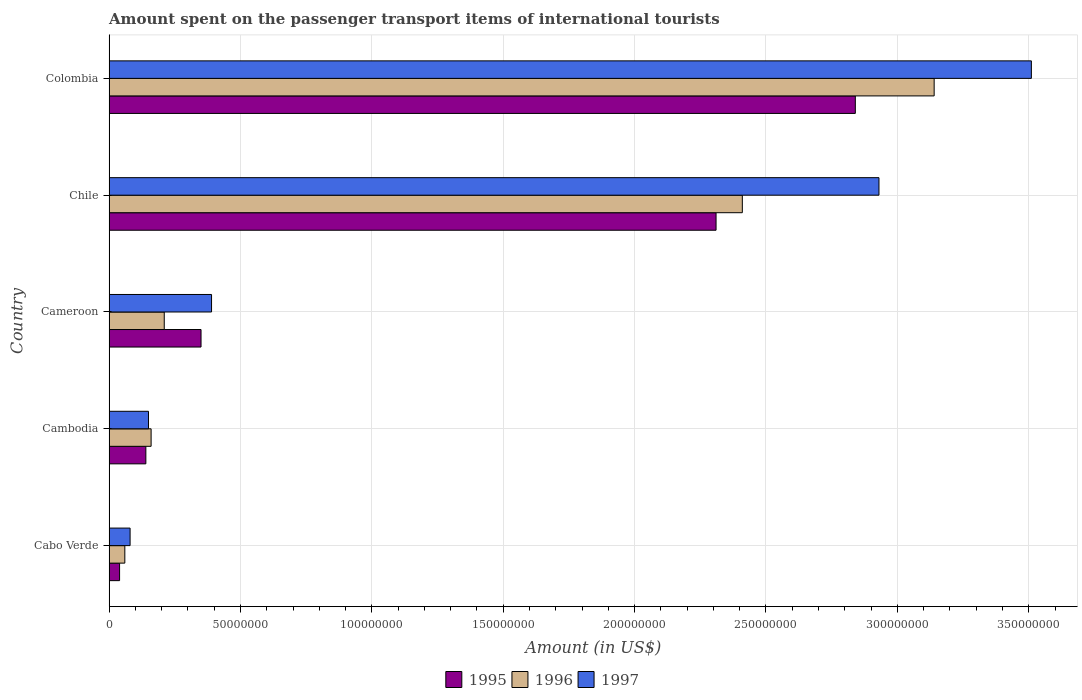How many different coloured bars are there?
Ensure brevity in your answer.  3. Are the number of bars per tick equal to the number of legend labels?
Your answer should be very brief. Yes. Are the number of bars on each tick of the Y-axis equal?
Ensure brevity in your answer.  Yes. How many bars are there on the 3rd tick from the bottom?
Your answer should be very brief. 3. What is the label of the 2nd group of bars from the top?
Ensure brevity in your answer.  Chile. In how many cases, is the number of bars for a given country not equal to the number of legend labels?
Your response must be concise. 0. What is the amount spent on the passenger transport items of international tourists in 1997 in Cambodia?
Your response must be concise. 1.50e+07. Across all countries, what is the maximum amount spent on the passenger transport items of international tourists in 1997?
Offer a very short reply. 3.51e+08. In which country was the amount spent on the passenger transport items of international tourists in 1995 maximum?
Your response must be concise. Colombia. In which country was the amount spent on the passenger transport items of international tourists in 1995 minimum?
Make the answer very short. Cabo Verde. What is the total amount spent on the passenger transport items of international tourists in 1997 in the graph?
Your answer should be very brief. 7.06e+08. What is the difference between the amount spent on the passenger transport items of international tourists in 1996 in Cabo Verde and that in Chile?
Your answer should be compact. -2.35e+08. What is the difference between the amount spent on the passenger transport items of international tourists in 1996 in Cameroon and the amount spent on the passenger transport items of international tourists in 1995 in Cabo Verde?
Ensure brevity in your answer.  1.70e+07. What is the average amount spent on the passenger transport items of international tourists in 1997 per country?
Offer a very short reply. 1.41e+08. In how many countries, is the amount spent on the passenger transport items of international tourists in 1996 greater than 350000000 US$?
Your answer should be very brief. 0. What is the ratio of the amount spent on the passenger transport items of international tourists in 1996 in Cabo Verde to that in Colombia?
Provide a short and direct response. 0.02. Is the difference between the amount spent on the passenger transport items of international tourists in 1997 in Cabo Verde and Cambodia greater than the difference between the amount spent on the passenger transport items of international tourists in 1996 in Cabo Verde and Cambodia?
Your answer should be compact. Yes. What is the difference between the highest and the second highest amount spent on the passenger transport items of international tourists in 1995?
Offer a very short reply. 5.30e+07. What is the difference between the highest and the lowest amount spent on the passenger transport items of international tourists in 1996?
Your answer should be compact. 3.08e+08. In how many countries, is the amount spent on the passenger transport items of international tourists in 1995 greater than the average amount spent on the passenger transport items of international tourists in 1995 taken over all countries?
Make the answer very short. 2. Is the sum of the amount spent on the passenger transport items of international tourists in 1997 in Cambodia and Cameroon greater than the maximum amount spent on the passenger transport items of international tourists in 1995 across all countries?
Your response must be concise. No. What does the 1st bar from the top in Colombia represents?
Your response must be concise. 1997. What does the 3rd bar from the bottom in Cambodia represents?
Your answer should be compact. 1997. How many bars are there?
Provide a short and direct response. 15. Are all the bars in the graph horizontal?
Keep it short and to the point. Yes. How many countries are there in the graph?
Offer a very short reply. 5. Does the graph contain any zero values?
Offer a terse response. No. Where does the legend appear in the graph?
Your answer should be compact. Bottom center. How many legend labels are there?
Your answer should be very brief. 3. How are the legend labels stacked?
Give a very brief answer. Horizontal. What is the title of the graph?
Offer a very short reply. Amount spent on the passenger transport items of international tourists. What is the Amount (in US$) in 1995 in Cabo Verde?
Offer a very short reply. 4.00e+06. What is the Amount (in US$) of 1995 in Cambodia?
Provide a succinct answer. 1.40e+07. What is the Amount (in US$) of 1996 in Cambodia?
Offer a terse response. 1.60e+07. What is the Amount (in US$) in 1997 in Cambodia?
Your answer should be compact. 1.50e+07. What is the Amount (in US$) in 1995 in Cameroon?
Give a very brief answer. 3.50e+07. What is the Amount (in US$) in 1996 in Cameroon?
Your answer should be compact. 2.10e+07. What is the Amount (in US$) in 1997 in Cameroon?
Keep it short and to the point. 3.90e+07. What is the Amount (in US$) of 1995 in Chile?
Your answer should be compact. 2.31e+08. What is the Amount (in US$) of 1996 in Chile?
Ensure brevity in your answer.  2.41e+08. What is the Amount (in US$) in 1997 in Chile?
Ensure brevity in your answer.  2.93e+08. What is the Amount (in US$) of 1995 in Colombia?
Your answer should be compact. 2.84e+08. What is the Amount (in US$) in 1996 in Colombia?
Provide a short and direct response. 3.14e+08. What is the Amount (in US$) in 1997 in Colombia?
Your response must be concise. 3.51e+08. Across all countries, what is the maximum Amount (in US$) of 1995?
Provide a succinct answer. 2.84e+08. Across all countries, what is the maximum Amount (in US$) of 1996?
Your response must be concise. 3.14e+08. Across all countries, what is the maximum Amount (in US$) of 1997?
Offer a terse response. 3.51e+08. Across all countries, what is the minimum Amount (in US$) of 1995?
Make the answer very short. 4.00e+06. What is the total Amount (in US$) of 1995 in the graph?
Your answer should be compact. 5.68e+08. What is the total Amount (in US$) in 1996 in the graph?
Keep it short and to the point. 5.98e+08. What is the total Amount (in US$) in 1997 in the graph?
Provide a short and direct response. 7.06e+08. What is the difference between the Amount (in US$) in 1995 in Cabo Verde and that in Cambodia?
Keep it short and to the point. -1.00e+07. What is the difference between the Amount (in US$) in 1996 in Cabo Verde and that in Cambodia?
Make the answer very short. -1.00e+07. What is the difference between the Amount (in US$) of 1997 in Cabo Verde and that in Cambodia?
Keep it short and to the point. -7.00e+06. What is the difference between the Amount (in US$) in 1995 in Cabo Verde and that in Cameroon?
Offer a terse response. -3.10e+07. What is the difference between the Amount (in US$) in 1996 in Cabo Verde and that in Cameroon?
Make the answer very short. -1.50e+07. What is the difference between the Amount (in US$) in 1997 in Cabo Verde and that in Cameroon?
Keep it short and to the point. -3.10e+07. What is the difference between the Amount (in US$) in 1995 in Cabo Verde and that in Chile?
Make the answer very short. -2.27e+08. What is the difference between the Amount (in US$) of 1996 in Cabo Verde and that in Chile?
Ensure brevity in your answer.  -2.35e+08. What is the difference between the Amount (in US$) of 1997 in Cabo Verde and that in Chile?
Keep it short and to the point. -2.85e+08. What is the difference between the Amount (in US$) in 1995 in Cabo Verde and that in Colombia?
Provide a succinct answer. -2.80e+08. What is the difference between the Amount (in US$) of 1996 in Cabo Verde and that in Colombia?
Offer a very short reply. -3.08e+08. What is the difference between the Amount (in US$) of 1997 in Cabo Verde and that in Colombia?
Your response must be concise. -3.43e+08. What is the difference between the Amount (in US$) in 1995 in Cambodia and that in Cameroon?
Offer a terse response. -2.10e+07. What is the difference between the Amount (in US$) of 1996 in Cambodia and that in Cameroon?
Your answer should be very brief. -5.00e+06. What is the difference between the Amount (in US$) of 1997 in Cambodia and that in Cameroon?
Make the answer very short. -2.40e+07. What is the difference between the Amount (in US$) in 1995 in Cambodia and that in Chile?
Your response must be concise. -2.17e+08. What is the difference between the Amount (in US$) in 1996 in Cambodia and that in Chile?
Offer a very short reply. -2.25e+08. What is the difference between the Amount (in US$) in 1997 in Cambodia and that in Chile?
Your answer should be compact. -2.78e+08. What is the difference between the Amount (in US$) of 1995 in Cambodia and that in Colombia?
Ensure brevity in your answer.  -2.70e+08. What is the difference between the Amount (in US$) of 1996 in Cambodia and that in Colombia?
Give a very brief answer. -2.98e+08. What is the difference between the Amount (in US$) in 1997 in Cambodia and that in Colombia?
Offer a terse response. -3.36e+08. What is the difference between the Amount (in US$) in 1995 in Cameroon and that in Chile?
Give a very brief answer. -1.96e+08. What is the difference between the Amount (in US$) in 1996 in Cameroon and that in Chile?
Make the answer very short. -2.20e+08. What is the difference between the Amount (in US$) of 1997 in Cameroon and that in Chile?
Make the answer very short. -2.54e+08. What is the difference between the Amount (in US$) of 1995 in Cameroon and that in Colombia?
Your answer should be very brief. -2.49e+08. What is the difference between the Amount (in US$) of 1996 in Cameroon and that in Colombia?
Give a very brief answer. -2.93e+08. What is the difference between the Amount (in US$) of 1997 in Cameroon and that in Colombia?
Keep it short and to the point. -3.12e+08. What is the difference between the Amount (in US$) in 1995 in Chile and that in Colombia?
Provide a succinct answer. -5.30e+07. What is the difference between the Amount (in US$) of 1996 in Chile and that in Colombia?
Keep it short and to the point. -7.30e+07. What is the difference between the Amount (in US$) of 1997 in Chile and that in Colombia?
Provide a short and direct response. -5.80e+07. What is the difference between the Amount (in US$) of 1995 in Cabo Verde and the Amount (in US$) of 1996 in Cambodia?
Ensure brevity in your answer.  -1.20e+07. What is the difference between the Amount (in US$) in 1995 in Cabo Verde and the Amount (in US$) in 1997 in Cambodia?
Ensure brevity in your answer.  -1.10e+07. What is the difference between the Amount (in US$) of 1996 in Cabo Verde and the Amount (in US$) of 1997 in Cambodia?
Your answer should be very brief. -9.00e+06. What is the difference between the Amount (in US$) of 1995 in Cabo Verde and the Amount (in US$) of 1996 in Cameroon?
Offer a terse response. -1.70e+07. What is the difference between the Amount (in US$) in 1995 in Cabo Verde and the Amount (in US$) in 1997 in Cameroon?
Give a very brief answer. -3.50e+07. What is the difference between the Amount (in US$) in 1996 in Cabo Verde and the Amount (in US$) in 1997 in Cameroon?
Provide a succinct answer. -3.30e+07. What is the difference between the Amount (in US$) in 1995 in Cabo Verde and the Amount (in US$) in 1996 in Chile?
Your answer should be very brief. -2.37e+08. What is the difference between the Amount (in US$) of 1995 in Cabo Verde and the Amount (in US$) of 1997 in Chile?
Offer a very short reply. -2.89e+08. What is the difference between the Amount (in US$) in 1996 in Cabo Verde and the Amount (in US$) in 1997 in Chile?
Offer a terse response. -2.87e+08. What is the difference between the Amount (in US$) in 1995 in Cabo Verde and the Amount (in US$) in 1996 in Colombia?
Your answer should be very brief. -3.10e+08. What is the difference between the Amount (in US$) of 1995 in Cabo Verde and the Amount (in US$) of 1997 in Colombia?
Your response must be concise. -3.47e+08. What is the difference between the Amount (in US$) in 1996 in Cabo Verde and the Amount (in US$) in 1997 in Colombia?
Your response must be concise. -3.45e+08. What is the difference between the Amount (in US$) in 1995 in Cambodia and the Amount (in US$) in 1996 in Cameroon?
Your response must be concise. -7.00e+06. What is the difference between the Amount (in US$) in 1995 in Cambodia and the Amount (in US$) in 1997 in Cameroon?
Your answer should be compact. -2.50e+07. What is the difference between the Amount (in US$) in 1996 in Cambodia and the Amount (in US$) in 1997 in Cameroon?
Keep it short and to the point. -2.30e+07. What is the difference between the Amount (in US$) in 1995 in Cambodia and the Amount (in US$) in 1996 in Chile?
Keep it short and to the point. -2.27e+08. What is the difference between the Amount (in US$) of 1995 in Cambodia and the Amount (in US$) of 1997 in Chile?
Give a very brief answer. -2.79e+08. What is the difference between the Amount (in US$) of 1996 in Cambodia and the Amount (in US$) of 1997 in Chile?
Ensure brevity in your answer.  -2.77e+08. What is the difference between the Amount (in US$) of 1995 in Cambodia and the Amount (in US$) of 1996 in Colombia?
Ensure brevity in your answer.  -3.00e+08. What is the difference between the Amount (in US$) of 1995 in Cambodia and the Amount (in US$) of 1997 in Colombia?
Your answer should be compact. -3.37e+08. What is the difference between the Amount (in US$) in 1996 in Cambodia and the Amount (in US$) in 1997 in Colombia?
Provide a short and direct response. -3.35e+08. What is the difference between the Amount (in US$) in 1995 in Cameroon and the Amount (in US$) in 1996 in Chile?
Your answer should be compact. -2.06e+08. What is the difference between the Amount (in US$) of 1995 in Cameroon and the Amount (in US$) of 1997 in Chile?
Offer a terse response. -2.58e+08. What is the difference between the Amount (in US$) of 1996 in Cameroon and the Amount (in US$) of 1997 in Chile?
Offer a very short reply. -2.72e+08. What is the difference between the Amount (in US$) in 1995 in Cameroon and the Amount (in US$) in 1996 in Colombia?
Your response must be concise. -2.79e+08. What is the difference between the Amount (in US$) of 1995 in Cameroon and the Amount (in US$) of 1997 in Colombia?
Ensure brevity in your answer.  -3.16e+08. What is the difference between the Amount (in US$) of 1996 in Cameroon and the Amount (in US$) of 1997 in Colombia?
Keep it short and to the point. -3.30e+08. What is the difference between the Amount (in US$) in 1995 in Chile and the Amount (in US$) in 1996 in Colombia?
Make the answer very short. -8.30e+07. What is the difference between the Amount (in US$) of 1995 in Chile and the Amount (in US$) of 1997 in Colombia?
Offer a terse response. -1.20e+08. What is the difference between the Amount (in US$) of 1996 in Chile and the Amount (in US$) of 1997 in Colombia?
Provide a succinct answer. -1.10e+08. What is the average Amount (in US$) of 1995 per country?
Your response must be concise. 1.14e+08. What is the average Amount (in US$) in 1996 per country?
Your response must be concise. 1.20e+08. What is the average Amount (in US$) in 1997 per country?
Make the answer very short. 1.41e+08. What is the difference between the Amount (in US$) of 1995 and Amount (in US$) of 1996 in Cabo Verde?
Your answer should be very brief. -2.00e+06. What is the difference between the Amount (in US$) in 1995 and Amount (in US$) in 1997 in Cabo Verde?
Offer a terse response. -4.00e+06. What is the difference between the Amount (in US$) in 1996 and Amount (in US$) in 1997 in Cambodia?
Offer a terse response. 1.00e+06. What is the difference between the Amount (in US$) of 1995 and Amount (in US$) of 1996 in Cameroon?
Offer a terse response. 1.40e+07. What is the difference between the Amount (in US$) of 1995 and Amount (in US$) of 1997 in Cameroon?
Your answer should be very brief. -4.00e+06. What is the difference between the Amount (in US$) of 1996 and Amount (in US$) of 1997 in Cameroon?
Your answer should be very brief. -1.80e+07. What is the difference between the Amount (in US$) of 1995 and Amount (in US$) of 1996 in Chile?
Keep it short and to the point. -1.00e+07. What is the difference between the Amount (in US$) of 1995 and Amount (in US$) of 1997 in Chile?
Make the answer very short. -6.20e+07. What is the difference between the Amount (in US$) in 1996 and Amount (in US$) in 1997 in Chile?
Offer a very short reply. -5.20e+07. What is the difference between the Amount (in US$) in 1995 and Amount (in US$) in 1996 in Colombia?
Offer a very short reply. -3.00e+07. What is the difference between the Amount (in US$) of 1995 and Amount (in US$) of 1997 in Colombia?
Offer a very short reply. -6.70e+07. What is the difference between the Amount (in US$) in 1996 and Amount (in US$) in 1997 in Colombia?
Your response must be concise. -3.70e+07. What is the ratio of the Amount (in US$) of 1995 in Cabo Verde to that in Cambodia?
Make the answer very short. 0.29. What is the ratio of the Amount (in US$) of 1997 in Cabo Verde to that in Cambodia?
Ensure brevity in your answer.  0.53. What is the ratio of the Amount (in US$) in 1995 in Cabo Verde to that in Cameroon?
Your response must be concise. 0.11. What is the ratio of the Amount (in US$) in 1996 in Cabo Verde to that in Cameroon?
Your answer should be compact. 0.29. What is the ratio of the Amount (in US$) of 1997 in Cabo Verde to that in Cameroon?
Keep it short and to the point. 0.21. What is the ratio of the Amount (in US$) in 1995 in Cabo Verde to that in Chile?
Offer a very short reply. 0.02. What is the ratio of the Amount (in US$) in 1996 in Cabo Verde to that in Chile?
Keep it short and to the point. 0.02. What is the ratio of the Amount (in US$) of 1997 in Cabo Verde to that in Chile?
Ensure brevity in your answer.  0.03. What is the ratio of the Amount (in US$) in 1995 in Cabo Verde to that in Colombia?
Offer a terse response. 0.01. What is the ratio of the Amount (in US$) of 1996 in Cabo Verde to that in Colombia?
Offer a terse response. 0.02. What is the ratio of the Amount (in US$) in 1997 in Cabo Verde to that in Colombia?
Make the answer very short. 0.02. What is the ratio of the Amount (in US$) of 1996 in Cambodia to that in Cameroon?
Ensure brevity in your answer.  0.76. What is the ratio of the Amount (in US$) in 1997 in Cambodia to that in Cameroon?
Your answer should be compact. 0.38. What is the ratio of the Amount (in US$) of 1995 in Cambodia to that in Chile?
Your answer should be compact. 0.06. What is the ratio of the Amount (in US$) in 1996 in Cambodia to that in Chile?
Your response must be concise. 0.07. What is the ratio of the Amount (in US$) of 1997 in Cambodia to that in Chile?
Give a very brief answer. 0.05. What is the ratio of the Amount (in US$) of 1995 in Cambodia to that in Colombia?
Make the answer very short. 0.05. What is the ratio of the Amount (in US$) of 1996 in Cambodia to that in Colombia?
Keep it short and to the point. 0.05. What is the ratio of the Amount (in US$) of 1997 in Cambodia to that in Colombia?
Keep it short and to the point. 0.04. What is the ratio of the Amount (in US$) of 1995 in Cameroon to that in Chile?
Provide a short and direct response. 0.15. What is the ratio of the Amount (in US$) of 1996 in Cameroon to that in Chile?
Ensure brevity in your answer.  0.09. What is the ratio of the Amount (in US$) of 1997 in Cameroon to that in Chile?
Your response must be concise. 0.13. What is the ratio of the Amount (in US$) in 1995 in Cameroon to that in Colombia?
Give a very brief answer. 0.12. What is the ratio of the Amount (in US$) of 1996 in Cameroon to that in Colombia?
Offer a very short reply. 0.07. What is the ratio of the Amount (in US$) of 1997 in Cameroon to that in Colombia?
Provide a short and direct response. 0.11. What is the ratio of the Amount (in US$) in 1995 in Chile to that in Colombia?
Your answer should be compact. 0.81. What is the ratio of the Amount (in US$) of 1996 in Chile to that in Colombia?
Provide a short and direct response. 0.77. What is the ratio of the Amount (in US$) in 1997 in Chile to that in Colombia?
Offer a very short reply. 0.83. What is the difference between the highest and the second highest Amount (in US$) in 1995?
Ensure brevity in your answer.  5.30e+07. What is the difference between the highest and the second highest Amount (in US$) in 1996?
Your answer should be very brief. 7.30e+07. What is the difference between the highest and the second highest Amount (in US$) of 1997?
Offer a terse response. 5.80e+07. What is the difference between the highest and the lowest Amount (in US$) in 1995?
Your answer should be very brief. 2.80e+08. What is the difference between the highest and the lowest Amount (in US$) in 1996?
Make the answer very short. 3.08e+08. What is the difference between the highest and the lowest Amount (in US$) of 1997?
Give a very brief answer. 3.43e+08. 